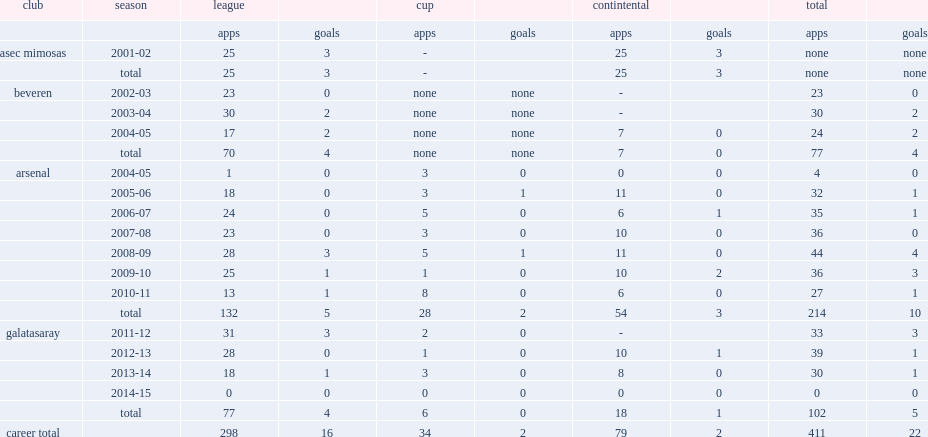How many goals did emmanuel eboue score for arsenal from 2005 to 2011? 10.0. 